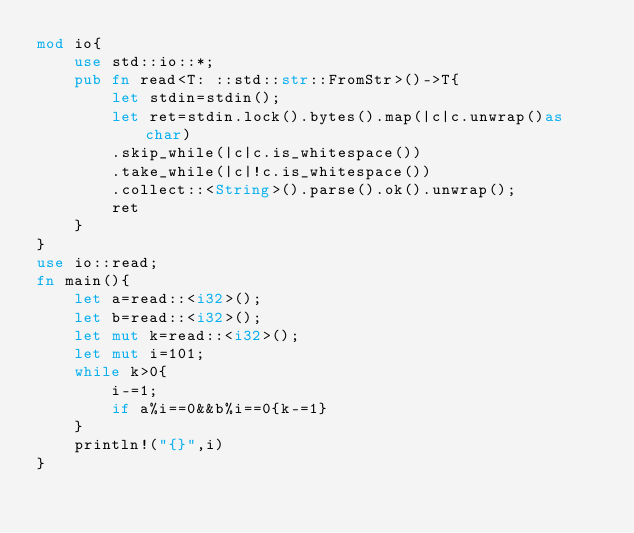Convert code to text. <code><loc_0><loc_0><loc_500><loc_500><_Rust_>mod io{
    use std::io::*;
    pub fn read<T: ::std::str::FromStr>()->T{
        let stdin=stdin();
        let ret=stdin.lock().bytes().map(|c|c.unwrap()as char)
        .skip_while(|c|c.is_whitespace())
        .take_while(|c|!c.is_whitespace())
        .collect::<String>().parse().ok().unwrap();
        ret
    }
}
use io::read;
fn main(){
    let a=read::<i32>();
    let b=read::<i32>();
    let mut k=read::<i32>();
    let mut i=101;
    while k>0{
        i-=1;
        if a%i==0&&b%i==0{k-=1}
    }
    println!("{}",i)
}</code> 